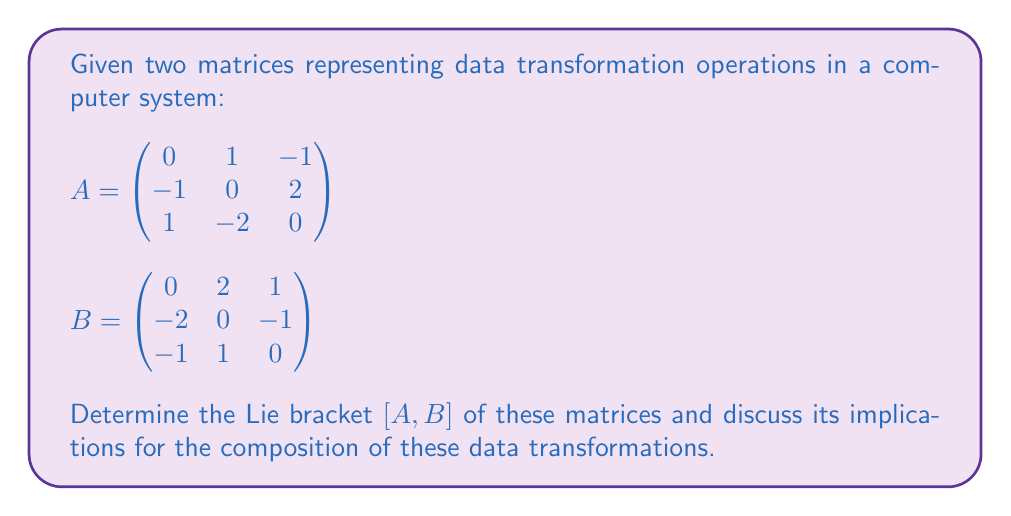What is the answer to this math problem? To solve this problem, we'll follow these steps:

1) Recall that the Lie bracket of two matrices $A$ and $B$ is defined as:

   $$[A,B] = AB - BA$$

2) First, we need to compute $AB$:

   $$AB = \begin{pmatrix} 0 & 1 & -1 \\ -1 & 0 & 2 \\ 1 & -2 & 0 \end{pmatrix} \begin{pmatrix} 0 & 2 & 1 \\ -2 & 0 & -1 \\ -1 & 1 & 0 \end{pmatrix}$$

   $$AB = \begin{pmatrix} -1 & -1 & -1 \\ -4 & 0 & -1 \\ 3 & -1 & 2 \end{pmatrix}$$

3) Next, we compute $BA$:

   $$BA = \begin{pmatrix} 0 & 2 & 1 \\ -2 & 0 & -1 \\ -1 & 1 & 0 \end{pmatrix} \begin{pmatrix} 0 & 1 & -1 \\ -1 & 0 & 2 \\ 1 & -2 & 0 \end{pmatrix}$$

   $$BA = \begin{pmatrix} -1 & -4 & 3 \\ -1 & 0 & -1 \\ -1 & -1 & 2 \end{pmatrix}$$

4) Now we can compute $[A,B] = AB - BA$:

   $$[A,B] = \begin{pmatrix} -1 & -1 & -1 \\ -4 & 0 & -1 \\ 3 & -1 & 2 \end{pmatrix} - \begin{pmatrix} -1 & -4 & 3 \\ -1 & 0 & -1 \\ -1 & -1 & 2 \end{pmatrix}$$

   $$[A,B] = \begin{pmatrix} 0 & 3 & -4 \\ -3 & 0 & 0 \\ 4 & 0 & 0 \end{pmatrix}$$

5) Implications for data transformations:
   The non-zero Lie bracket indicates that these transformations do not commute. In the context of data transformations, this means that the order in which we apply transformations A and B matters. Applying A then B will yield a different result than applying B then A. This non-commutativity is crucial in understanding how these transformations interact and in designing systems that use them sequentially.
Answer: The Lie bracket $[A,B]$ is:

$$[A,B] = \begin{pmatrix} 0 & 3 & -4 \\ -3 & 0 & 0 \\ 4 & 0 & 0 \end{pmatrix}$$

This non-zero result implies that the data transformations represented by matrices A and B do not commute, meaning the order of their application affects the final outcome. 